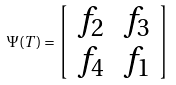Convert formula to latex. <formula><loc_0><loc_0><loc_500><loc_500>\Psi ( T ) = \left [ \begin{array} { l r } f _ { 2 } & f _ { 3 } \\ f _ { 4 } & f _ { 1 } \end{array} \right ]</formula> 